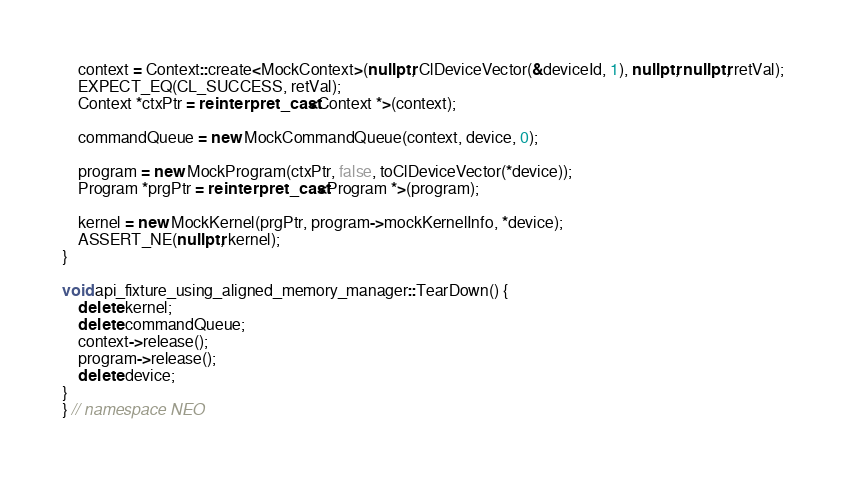Convert code to text. <code><loc_0><loc_0><loc_500><loc_500><_C++_>    context = Context::create<MockContext>(nullptr, ClDeviceVector(&deviceId, 1), nullptr, nullptr, retVal);
    EXPECT_EQ(CL_SUCCESS, retVal);
    Context *ctxPtr = reinterpret_cast<Context *>(context);

    commandQueue = new MockCommandQueue(context, device, 0);

    program = new MockProgram(ctxPtr, false, toClDeviceVector(*device));
    Program *prgPtr = reinterpret_cast<Program *>(program);

    kernel = new MockKernel(prgPtr, program->mockKernelInfo, *device);
    ASSERT_NE(nullptr, kernel);
}

void api_fixture_using_aligned_memory_manager::TearDown() {
    delete kernel;
    delete commandQueue;
    context->release();
    program->release();
    delete device;
}
} // namespace NEO
</code> 